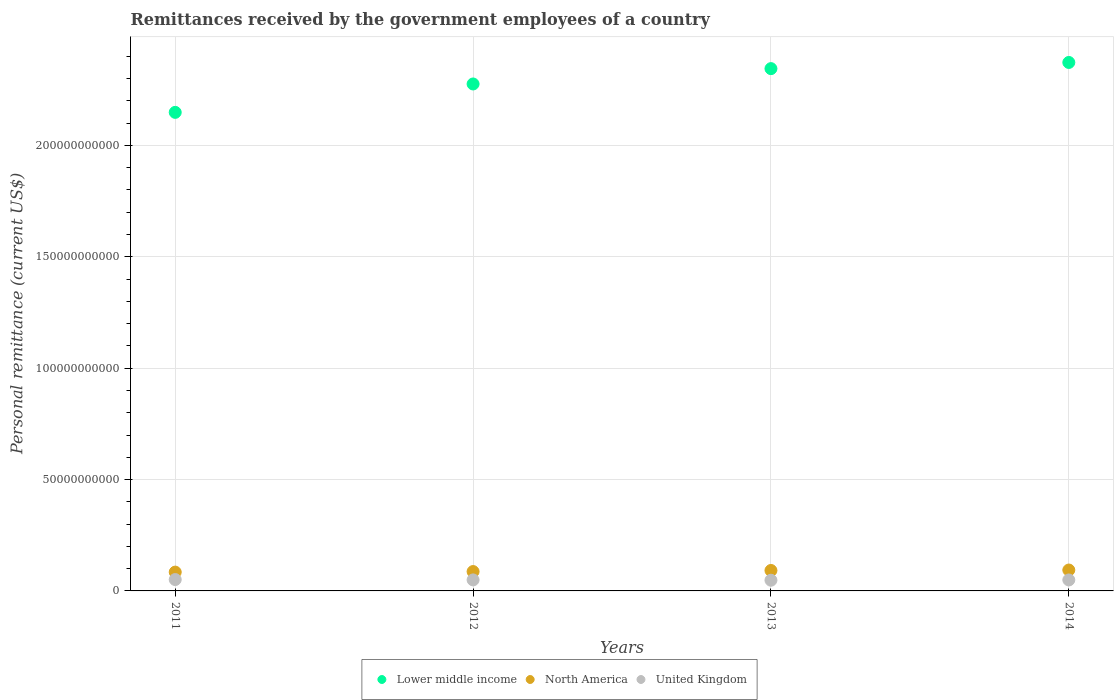How many different coloured dotlines are there?
Your response must be concise. 3. What is the remittances received by the government employees in Lower middle income in 2014?
Offer a very short reply. 2.37e+11. Across all years, what is the maximum remittances received by the government employees in United Kingdom?
Your answer should be compact. 5.10e+09. Across all years, what is the minimum remittances received by the government employees in North America?
Provide a short and direct response. 8.45e+09. In which year was the remittances received by the government employees in United Kingdom minimum?
Keep it short and to the point. 2013. What is the total remittances received by the government employees in United Kingdom in the graph?
Offer a terse response. 1.98e+1. What is the difference between the remittances received by the government employees in Lower middle income in 2011 and that in 2012?
Keep it short and to the point. -1.27e+1. What is the difference between the remittances received by the government employees in North America in 2011 and the remittances received by the government employees in Lower middle income in 2013?
Keep it short and to the point. -2.26e+11. What is the average remittances received by the government employees in North America per year?
Your answer should be compact. 8.93e+09. In the year 2013, what is the difference between the remittances received by the government employees in North America and remittances received by the government employees in Lower middle income?
Ensure brevity in your answer.  -2.25e+11. What is the ratio of the remittances received by the government employees in Lower middle income in 2011 to that in 2012?
Make the answer very short. 0.94. Is the remittances received by the government employees in United Kingdom in 2011 less than that in 2013?
Offer a very short reply. No. What is the difference between the highest and the second highest remittances received by the government employees in Lower middle income?
Your response must be concise. 2.77e+09. What is the difference between the highest and the lowest remittances received by the government employees in North America?
Provide a short and direct response. 9.36e+08. Is the sum of the remittances received by the government employees in Lower middle income in 2012 and 2014 greater than the maximum remittances received by the government employees in United Kingdom across all years?
Provide a succinct answer. Yes. Is the remittances received by the government employees in North America strictly less than the remittances received by the government employees in United Kingdom over the years?
Offer a very short reply. No. How many years are there in the graph?
Your answer should be compact. 4. How many legend labels are there?
Give a very brief answer. 3. What is the title of the graph?
Make the answer very short. Remittances received by the government employees of a country. What is the label or title of the Y-axis?
Keep it short and to the point. Personal remittance (current US$). What is the Personal remittance (current US$) in Lower middle income in 2011?
Give a very brief answer. 2.15e+11. What is the Personal remittance (current US$) of North America in 2011?
Ensure brevity in your answer.  8.45e+09. What is the Personal remittance (current US$) in United Kingdom in 2011?
Ensure brevity in your answer.  5.10e+09. What is the Personal remittance (current US$) in Lower middle income in 2012?
Offer a very short reply. 2.28e+11. What is the Personal remittance (current US$) of North America in 2012?
Provide a succinct answer. 8.70e+09. What is the Personal remittance (current US$) of United Kingdom in 2012?
Offer a very short reply. 4.94e+09. What is the Personal remittance (current US$) of Lower middle income in 2013?
Provide a succinct answer. 2.34e+11. What is the Personal remittance (current US$) of North America in 2013?
Provide a succinct answer. 9.18e+09. What is the Personal remittance (current US$) of United Kingdom in 2013?
Offer a very short reply. 4.80e+09. What is the Personal remittance (current US$) of Lower middle income in 2014?
Make the answer very short. 2.37e+11. What is the Personal remittance (current US$) of North America in 2014?
Provide a succinct answer. 9.38e+09. What is the Personal remittance (current US$) of United Kingdom in 2014?
Give a very brief answer. 4.92e+09. Across all years, what is the maximum Personal remittance (current US$) in Lower middle income?
Keep it short and to the point. 2.37e+11. Across all years, what is the maximum Personal remittance (current US$) of North America?
Your answer should be very brief. 9.38e+09. Across all years, what is the maximum Personal remittance (current US$) in United Kingdom?
Make the answer very short. 5.10e+09. Across all years, what is the minimum Personal remittance (current US$) of Lower middle income?
Ensure brevity in your answer.  2.15e+11. Across all years, what is the minimum Personal remittance (current US$) of North America?
Offer a terse response. 8.45e+09. Across all years, what is the minimum Personal remittance (current US$) in United Kingdom?
Your answer should be very brief. 4.80e+09. What is the total Personal remittance (current US$) of Lower middle income in the graph?
Offer a very short reply. 9.14e+11. What is the total Personal remittance (current US$) of North America in the graph?
Your answer should be compact. 3.57e+1. What is the total Personal remittance (current US$) in United Kingdom in the graph?
Provide a succinct answer. 1.98e+1. What is the difference between the Personal remittance (current US$) of Lower middle income in 2011 and that in 2012?
Provide a succinct answer. -1.27e+1. What is the difference between the Personal remittance (current US$) of North America in 2011 and that in 2012?
Provide a succinct answer. -2.53e+08. What is the difference between the Personal remittance (current US$) in United Kingdom in 2011 and that in 2012?
Your answer should be very brief. 1.54e+08. What is the difference between the Personal remittance (current US$) of Lower middle income in 2011 and that in 2013?
Your answer should be very brief. -1.96e+1. What is the difference between the Personal remittance (current US$) in North America in 2011 and that in 2013?
Your response must be concise. -7.35e+08. What is the difference between the Personal remittance (current US$) in United Kingdom in 2011 and that in 2013?
Your answer should be compact. 2.95e+08. What is the difference between the Personal remittance (current US$) of Lower middle income in 2011 and that in 2014?
Provide a short and direct response. -2.24e+1. What is the difference between the Personal remittance (current US$) of North America in 2011 and that in 2014?
Ensure brevity in your answer.  -9.36e+08. What is the difference between the Personal remittance (current US$) of United Kingdom in 2011 and that in 2014?
Provide a short and direct response. 1.76e+08. What is the difference between the Personal remittance (current US$) in Lower middle income in 2012 and that in 2013?
Provide a short and direct response. -6.89e+09. What is the difference between the Personal remittance (current US$) in North America in 2012 and that in 2013?
Offer a very short reply. -4.82e+08. What is the difference between the Personal remittance (current US$) of United Kingdom in 2012 and that in 2013?
Offer a terse response. 1.40e+08. What is the difference between the Personal remittance (current US$) in Lower middle income in 2012 and that in 2014?
Keep it short and to the point. -9.66e+09. What is the difference between the Personal remittance (current US$) in North America in 2012 and that in 2014?
Your answer should be compact. -6.83e+08. What is the difference between the Personal remittance (current US$) of United Kingdom in 2012 and that in 2014?
Provide a short and direct response. 2.19e+07. What is the difference between the Personal remittance (current US$) in Lower middle income in 2013 and that in 2014?
Your answer should be compact. -2.77e+09. What is the difference between the Personal remittance (current US$) in North America in 2013 and that in 2014?
Provide a short and direct response. -2.01e+08. What is the difference between the Personal remittance (current US$) in United Kingdom in 2013 and that in 2014?
Make the answer very short. -1.18e+08. What is the difference between the Personal remittance (current US$) in Lower middle income in 2011 and the Personal remittance (current US$) in North America in 2012?
Your answer should be compact. 2.06e+11. What is the difference between the Personal remittance (current US$) in Lower middle income in 2011 and the Personal remittance (current US$) in United Kingdom in 2012?
Make the answer very short. 2.10e+11. What is the difference between the Personal remittance (current US$) of North America in 2011 and the Personal remittance (current US$) of United Kingdom in 2012?
Keep it short and to the point. 3.50e+09. What is the difference between the Personal remittance (current US$) in Lower middle income in 2011 and the Personal remittance (current US$) in North America in 2013?
Offer a terse response. 2.06e+11. What is the difference between the Personal remittance (current US$) of Lower middle income in 2011 and the Personal remittance (current US$) of United Kingdom in 2013?
Provide a short and direct response. 2.10e+11. What is the difference between the Personal remittance (current US$) in North America in 2011 and the Personal remittance (current US$) in United Kingdom in 2013?
Your response must be concise. 3.64e+09. What is the difference between the Personal remittance (current US$) of Lower middle income in 2011 and the Personal remittance (current US$) of North America in 2014?
Your answer should be very brief. 2.05e+11. What is the difference between the Personal remittance (current US$) of Lower middle income in 2011 and the Personal remittance (current US$) of United Kingdom in 2014?
Ensure brevity in your answer.  2.10e+11. What is the difference between the Personal remittance (current US$) in North America in 2011 and the Personal remittance (current US$) in United Kingdom in 2014?
Ensure brevity in your answer.  3.52e+09. What is the difference between the Personal remittance (current US$) of Lower middle income in 2012 and the Personal remittance (current US$) of North America in 2013?
Ensure brevity in your answer.  2.18e+11. What is the difference between the Personal remittance (current US$) of Lower middle income in 2012 and the Personal remittance (current US$) of United Kingdom in 2013?
Your response must be concise. 2.23e+11. What is the difference between the Personal remittance (current US$) in North America in 2012 and the Personal remittance (current US$) in United Kingdom in 2013?
Provide a succinct answer. 3.89e+09. What is the difference between the Personal remittance (current US$) in Lower middle income in 2012 and the Personal remittance (current US$) in North America in 2014?
Provide a short and direct response. 2.18e+11. What is the difference between the Personal remittance (current US$) in Lower middle income in 2012 and the Personal remittance (current US$) in United Kingdom in 2014?
Your answer should be very brief. 2.23e+11. What is the difference between the Personal remittance (current US$) in North America in 2012 and the Personal remittance (current US$) in United Kingdom in 2014?
Make the answer very short. 3.78e+09. What is the difference between the Personal remittance (current US$) in Lower middle income in 2013 and the Personal remittance (current US$) in North America in 2014?
Provide a succinct answer. 2.25e+11. What is the difference between the Personal remittance (current US$) in Lower middle income in 2013 and the Personal remittance (current US$) in United Kingdom in 2014?
Offer a terse response. 2.30e+11. What is the difference between the Personal remittance (current US$) of North America in 2013 and the Personal remittance (current US$) of United Kingdom in 2014?
Keep it short and to the point. 4.26e+09. What is the average Personal remittance (current US$) of Lower middle income per year?
Your answer should be compact. 2.29e+11. What is the average Personal remittance (current US$) in North America per year?
Provide a succinct answer. 8.93e+09. What is the average Personal remittance (current US$) of United Kingdom per year?
Offer a terse response. 4.94e+09. In the year 2011, what is the difference between the Personal remittance (current US$) of Lower middle income and Personal remittance (current US$) of North America?
Provide a short and direct response. 2.06e+11. In the year 2011, what is the difference between the Personal remittance (current US$) of Lower middle income and Personal remittance (current US$) of United Kingdom?
Your answer should be compact. 2.10e+11. In the year 2011, what is the difference between the Personal remittance (current US$) of North America and Personal remittance (current US$) of United Kingdom?
Your response must be concise. 3.35e+09. In the year 2012, what is the difference between the Personal remittance (current US$) of Lower middle income and Personal remittance (current US$) of North America?
Provide a short and direct response. 2.19e+11. In the year 2012, what is the difference between the Personal remittance (current US$) in Lower middle income and Personal remittance (current US$) in United Kingdom?
Provide a succinct answer. 2.23e+11. In the year 2012, what is the difference between the Personal remittance (current US$) in North America and Personal remittance (current US$) in United Kingdom?
Offer a terse response. 3.75e+09. In the year 2013, what is the difference between the Personal remittance (current US$) of Lower middle income and Personal remittance (current US$) of North America?
Make the answer very short. 2.25e+11. In the year 2013, what is the difference between the Personal remittance (current US$) in Lower middle income and Personal remittance (current US$) in United Kingdom?
Your answer should be very brief. 2.30e+11. In the year 2013, what is the difference between the Personal remittance (current US$) in North America and Personal remittance (current US$) in United Kingdom?
Your response must be concise. 4.38e+09. In the year 2014, what is the difference between the Personal remittance (current US$) of Lower middle income and Personal remittance (current US$) of North America?
Your response must be concise. 2.28e+11. In the year 2014, what is the difference between the Personal remittance (current US$) in Lower middle income and Personal remittance (current US$) in United Kingdom?
Provide a short and direct response. 2.32e+11. In the year 2014, what is the difference between the Personal remittance (current US$) of North America and Personal remittance (current US$) of United Kingdom?
Make the answer very short. 4.46e+09. What is the ratio of the Personal remittance (current US$) of Lower middle income in 2011 to that in 2012?
Make the answer very short. 0.94. What is the ratio of the Personal remittance (current US$) of North America in 2011 to that in 2012?
Your answer should be compact. 0.97. What is the ratio of the Personal remittance (current US$) of United Kingdom in 2011 to that in 2012?
Make the answer very short. 1.03. What is the ratio of the Personal remittance (current US$) of Lower middle income in 2011 to that in 2013?
Ensure brevity in your answer.  0.92. What is the ratio of the Personal remittance (current US$) in North America in 2011 to that in 2013?
Make the answer very short. 0.92. What is the ratio of the Personal remittance (current US$) in United Kingdom in 2011 to that in 2013?
Your answer should be compact. 1.06. What is the ratio of the Personal remittance (current US$) of Lower middle income in 2011 to that in 2014?
Provide a short and direct response. 0.91. What is the ratio of the Personal remittance (current US$) of North America in 2011 to that in 2014?
Provide a short and direct response. 0.9. What is the ratio of the Personal remittance (current US$) in United Kingdom in 2011 to that in 2014?
Give a very brief answer. 1.04. What is the ratio of the Personal remittance (current US$) in Lower middle income in 2012 to that in 2013?
Keep it short and to the point. 0.97. What is the ratio of the Personal remittance (current US$) of North America in 2012 to that in 2013?
Offer a very short reply. 0.95. What is the ratio of the Personal remittance (current US$) in United Kingdom in 2012 to that in 2013?
Keep it short and to the point. 1.03. What is the ratio of the Personal remittance (current US$) of Lower middle income in 2012 to that in 2014?
Offer a terse response. 0.96. What is the ratio of the Personal remittance (current US$) in North America in 2012 to that in 2014?
Offer a very short reply. 0.93. What is the ratio of the Personal remittance (current US$) in United Kingdom in 2012 to that in 2014?
Give a very brief answer. 1. What is the ratio of the Personal remittance (current US$) of Lower middle income in 2013 to that in 2014?
Give a very brief answer. 0.99. What is the ratio of the Personal remittance (current US$) in North America in 2013 to that in 2014?
Make the answer very short. 0.98. What is the difference between the highest and the second highest Personal remittance (current US$) of Lower middle income?
Offer a very short reply. 2.77e+09. What is the difference between the highest and the second highest Personal remittance (current US$) in North America?
Ensure brevity in your answer.  2.01e+08. What is the difference between the highest and the second highest Personal remittance (current US$) of United Kingdom?
Ensure brevity in your answer.  1.54e+08. What is the difference between the highest and the lowest Personal remittance (current US$) of Lower middle income?
Give a very brief answer. 2.24e+1. What is the difference between the highest and the lowest Personal remittance (current US$) in North America?
Your answer should be very brief. 9.36e+08. What is the difference between the highest and the lowest Personal remittance (current US$) of United Kingdom?
Offer a very short reply. 2.95e+08. 